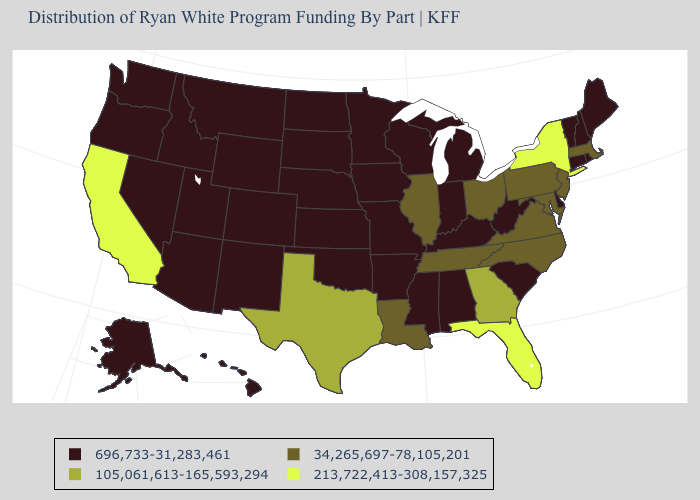Name the states that have a value in the range 696,733-31,283,461?
Give a very brief answer. Alabama, Alaska, Arizona, Arkansas, Colorado, Connecticut, Delaware, Hawaii, Idaho, Indiana, Iowa, Kansas, Kentucky, Maine, Michigan, Minnesota, Mississippi, Missouri, Montana, Nebraska, Nevada, New Hampshire, New Mexico, North Dakota, Oklahoma, Oregon, Rhode Island, South Carolina, South Dakota, Utah, Vermont, Washington, West Virginia, Wisconsin, Wyoming. Among the states that border New York , does Pennsylvania have the highest value?
Quick response, please. Yes. Which states have the lowest value in the West?
Concise answer only. Alaska, Arizona, Colorado, Hawaii, Idaho, Montana, Nevada, New Mexico, Oregon, Utah, Washington, Wyoming. What is the highest value in the Northeast ?
Short answer required. 213,722,413-308,157,325. Among the states that border Virginia , does Tennessee have the highest value?
Be succinct. Yes. Among the states that border Oregon , does California have the highest value?
Short answer required. Yes. What is the highest value in states that border New Jersey?
Keep it brief. 213,722,413-308,157,325. Does New Jersey have the lowest value in the USA?
Write a very short answer. No. Name the states that have a value in the range 105,061,613-165,593,294?
Short answer required. Georgia, Texas. Which states have the lowest value in the South?
Be succinct. Alabama, Arkansas, Delaware, Kentucky, Mississippi, Oklahoma, South Carolina, West Virginia. Which states have the lowest value in the USA?
Answer briefly. Alabama, Alaska, Arizona, Arkansas, Colorado, Connecticut, Delaware, Hawaii, Idaho, Indiana, Iowa, Kansas, Kentucky, Maine, Michigan, Minnesota, Mississippi, Missouri, Montana, Nebraska, Nevada, New Hampshire, New Mexico, North Dakota, Oklahoma, Oregon, Rhode Island, South Carolina, South Dakota, Utah, Vermont, Washington, West Virginia, Wisconsin, Wyoming. What is the highest value in the USA?
Quick response, please. 213,722,413-308,157,325. Name the states that have a value in the range 213,722,413-308,157,325?
Give a very brief answer. California, Florida, New York. What is the value of Florida?
Be succinct. 213,722,413-308,157,325. 